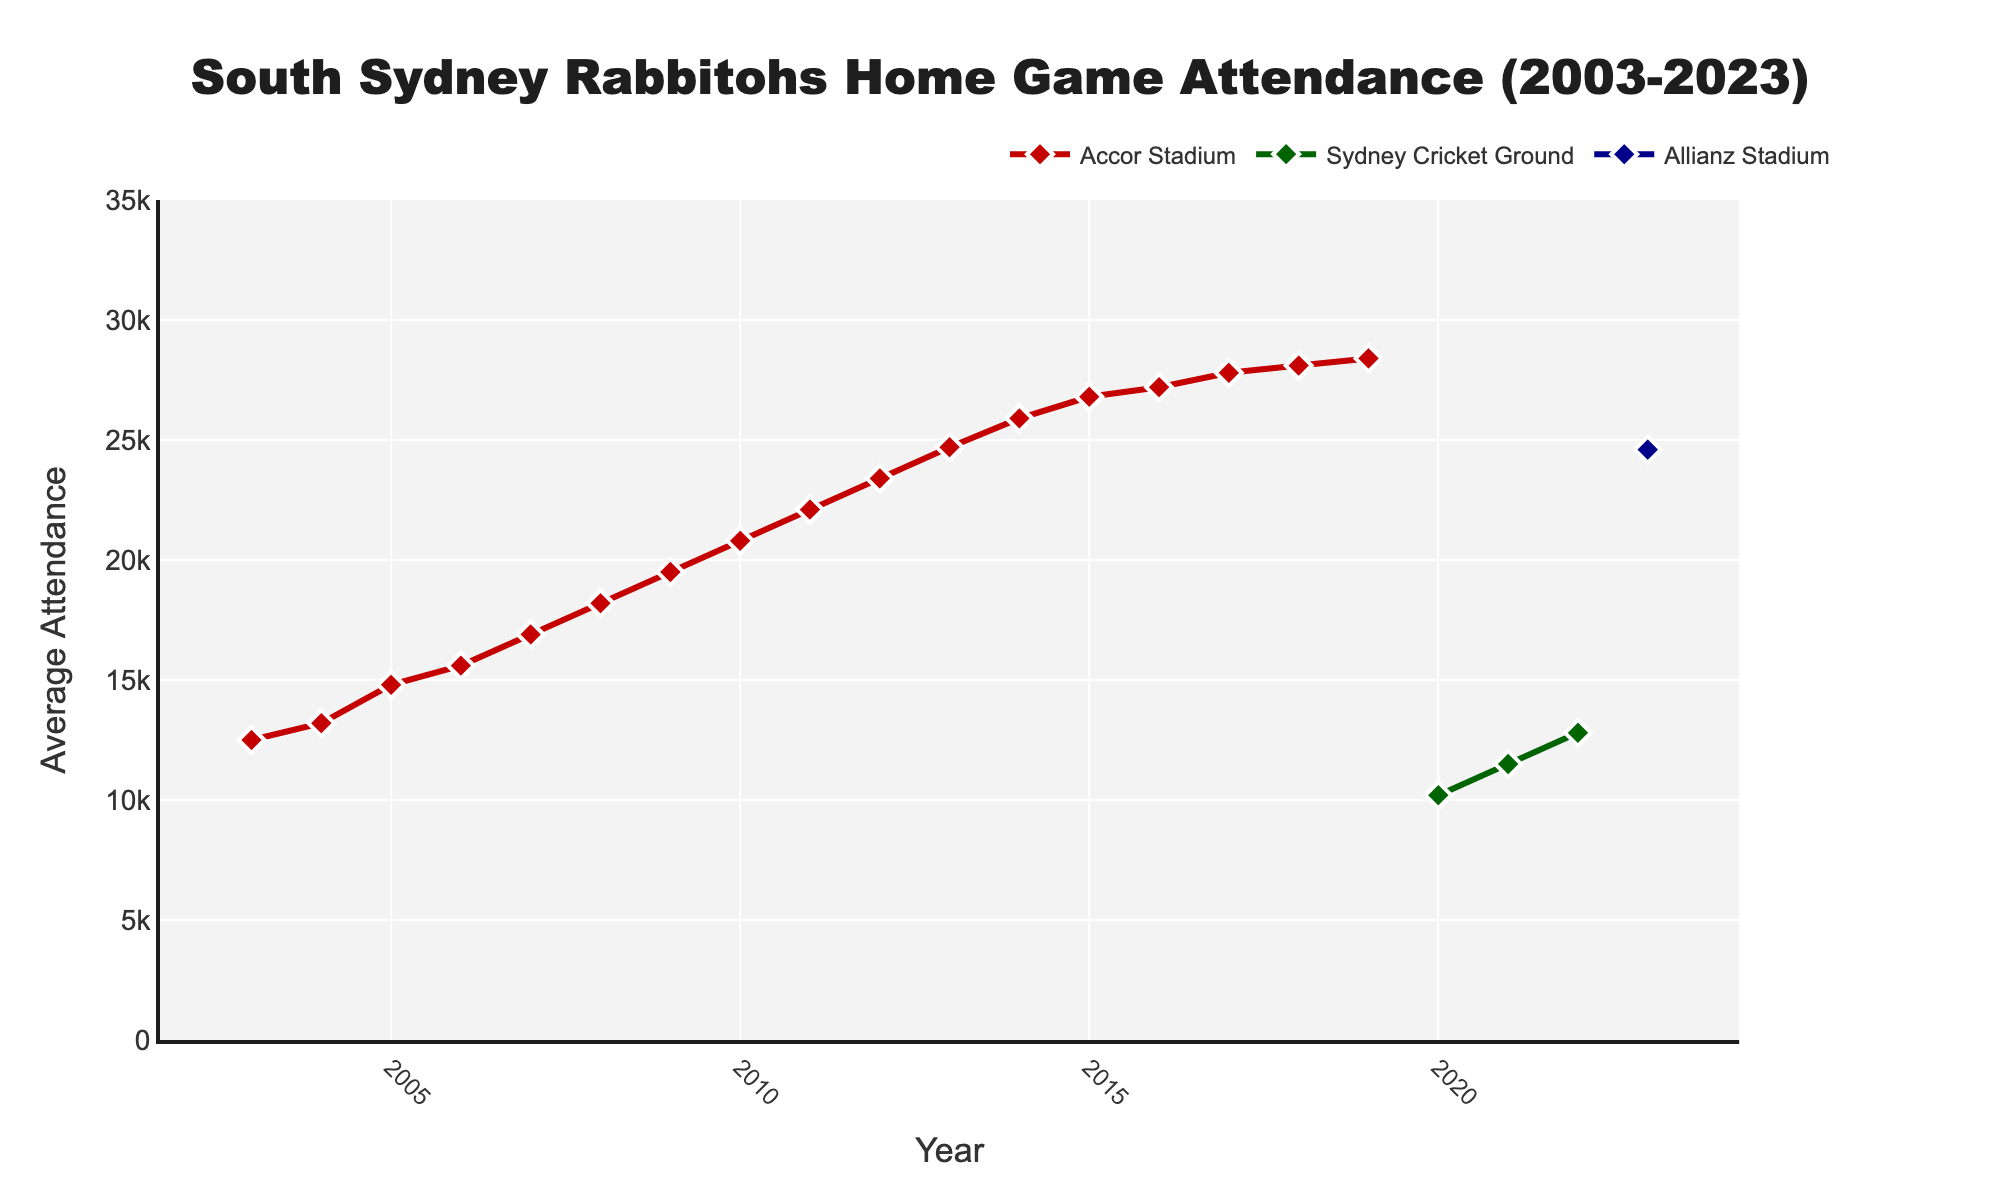What's the initial attendance at Accor Stadium in 2003? Look at the plot and find the attendance value corresponding to the year 2003 for the Accor Stadium line, which should be the starting point of the red line.
Answer: 12500 How many times did the average attendance at Accor Stadium increase between 2003 and 2019? Identify the initial value in 2003 and the final value in 2019 for Accor Stadium, then count each year as an increase if it's higher than the previous year's attendance.
Answer: 16 times Which stadium had the highest average attendance in 2023? Observe the different lines in the chart and note their values for 2023. Compare these values to identify the stadium with the highest attendance.
Answer: Allianz Stadium When did Accor Stadium see its highest average attendance and what was it? Review the peaks of the Accor Stadium line and locate the year of the highest peak and its corresponding attendance.
Answer: 2019, 28400 By how much did the average attendance at Sydney Cricket Ground (SCG) increase from 2020 to 2022? Determine the attendance at SCG for 2020 and 2022, then calculate the difference between these two values.
Answer: 2600 Compare the attendance in 2020 for SCG and Accor Stadium. Which was higher? Find the attendance values for both SCG and Accor Stadium in 2020 and directly compare them to establish which one was higher.
Answer: SCG What is the percentage increase in average attendance from 2003 to 2019 at Accor Stadium? Calculate the attendance in 2019 minus the attendance in 2003, divide by the attendance in 2003, and then multiply by 100 to find the percentage increase.
Answer: 127.2% Which years did Accor Stadium have an average attendance equal to or greater than 25000? Identify the years on the Accor Stadium line where the attendance values meet or exceed 25000.
Answer: 2014 to 2019 Is there any year where average attendance decreased compared to the previous year for Accor Stadium? Review the Accor Stadium line to check if there is any year where the attendance dropped compared to the previous year.
Answer: No Which stadium shows a constant increase in attendance over the years they are plotted? Analyze the trend lines for Accor Stadium, SCG, and Allianz Stadium to see if any show a consistent increase without drops.
Answer: SCG 